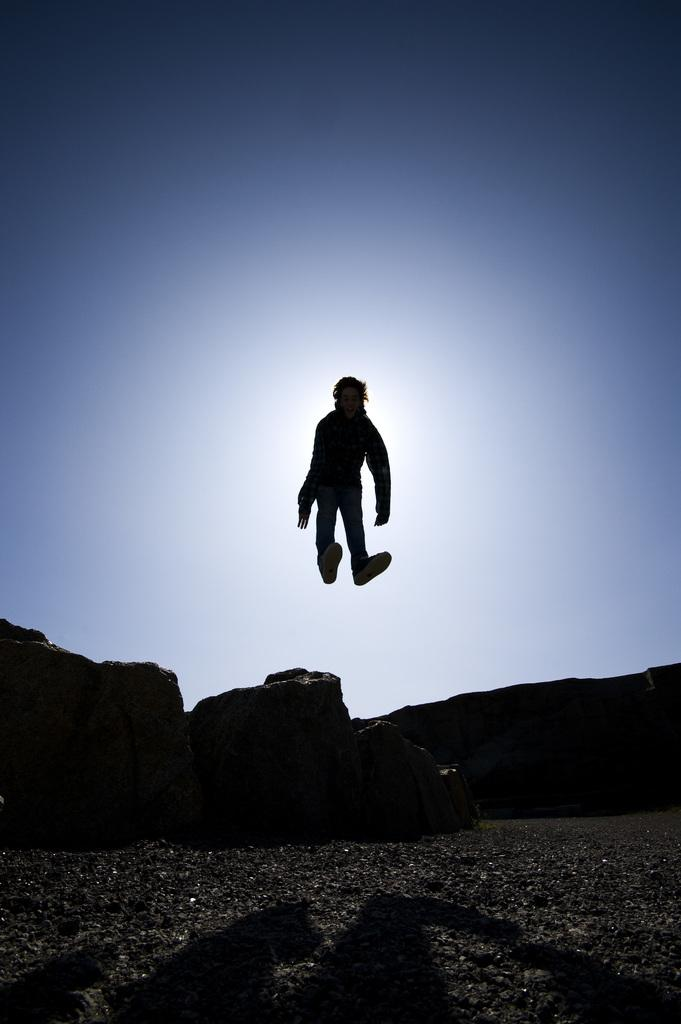What type of surface is at the bottom of the image? There are gravel stones at the bottom of the image. What can be seen in the center of the image? There are rocks in the center of the image. What is the person in the image doing? The person is jumping in the middle of the image. What is visible in the background of the image? The sky is visible in the background of the image. Where are the cakes placed on the plate in the image? There are no cakes or plates present in the image. What type of scene is depicted in the image? The image does not depict a scene; it shows a person jumping amidst rocks and gravel stones. 